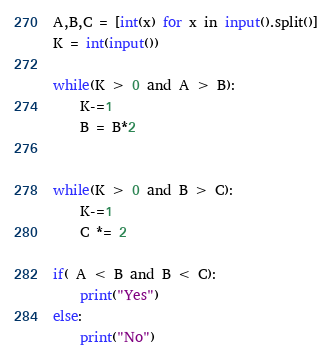Convert code to text. <code><loc_0><loc_0><loc_500><loc_500><_Python_>A,B,C = [int(x) for x in input().split()]
K = int(input())

while(K > 0 and A > B):
    K-=1
    B = B*2


while(K > 0 and B > C):
    K-=1
    C *= 2

if( A < B and B < C):
    print("Yes")
else:
    print("No")
</code> 